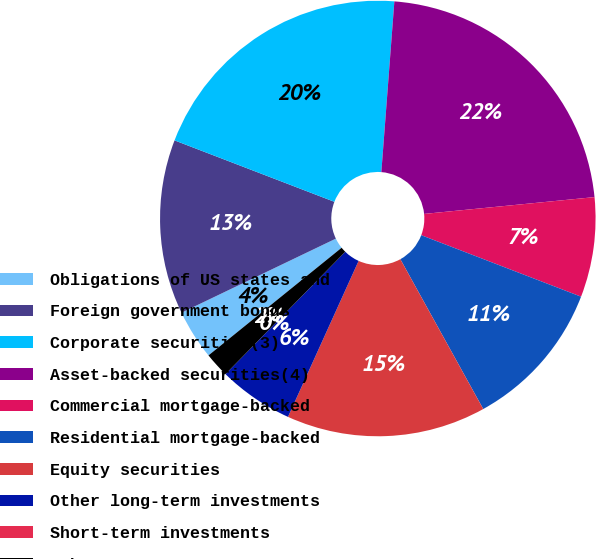Convert chart to OTSL. <chart><loc_0><loc_0><loc_500><loc_500><pie_chart><fcel>Obligations of US states and<fcel>Foreign government bonds<fcel>Corporate securities(3)<fcel>Asset-backed securities(4)<fcel>Commercial mortgage-backed<fcel>Residential mortgage-backed<fcel>Equity securities<fcel>Other long-term investments<fcel>Short-term investments<fcel>Other assets<nl><fcel>3.7%<fcel>12.96%<fcel>20.37%<fcel>22.22%<fcel>7.41%<fcel>11.11%<fcel>14.81%<fcel>5.56%<fcel>0.0%<fcel>1.85%<nl></chart> 